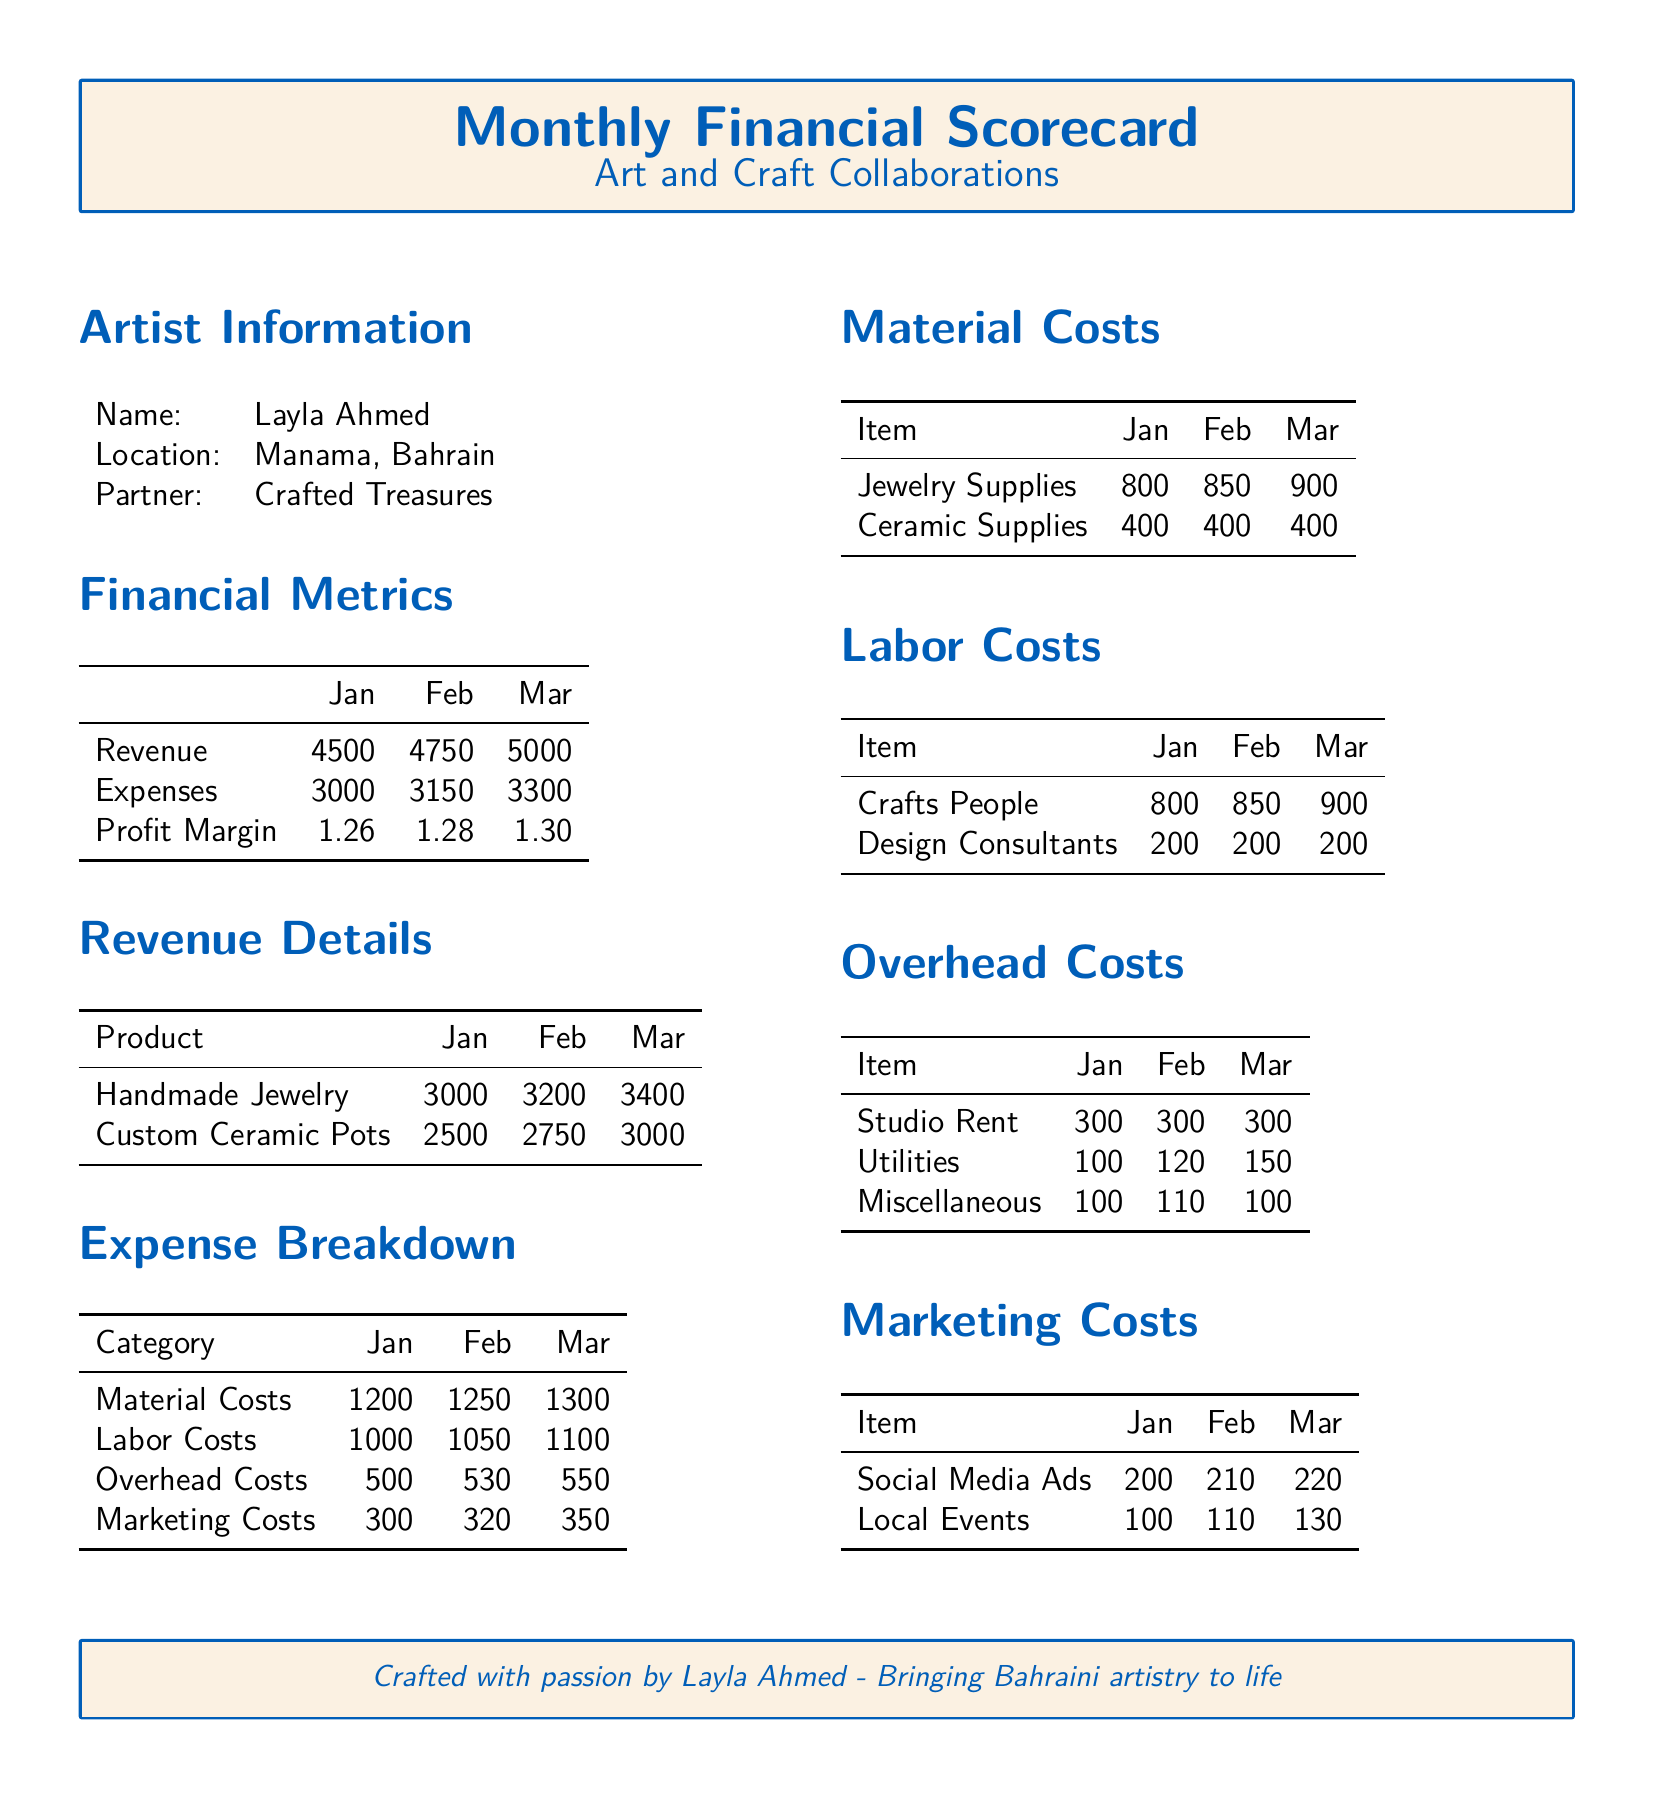What is the total revenue for March? The total revenue for March can be found in the financial metrics section of the document.
Answer: 5000 What are the total expenses for February? The total expenses for February are listed in the financial metrics section of the document.
Answer: 3150 What is the profit margin for January? The profit margin for January is found in the financial metrics section, where it is stated explicitly.
Answer: 1.26 How much did the handmade jewelry revenue increase from January to March? The increase in revenue for handmade jewelry can be calculated by comparing the values from January and March.
Answer: 400 What category had the highest expense in March? The expense category with the highest value can be determined by looking at the expense breakdown for March.
Answer: Labor Costs What were the marketing costs in January? The marketing costs for January are specifically detailed in the expense breakdown section.
Answer: 300 How many items are listed under Material Costs? The document lists the items under Material Costs, and we can count them for the answer.
Answer: 2 Who is the partner in the collaboration? The partner is named in the artist information section of the document.
Answer: Crafted Treasures What was the increase in utility costs from February to March? The increase in utility costs can be derived from the numbers given for those months in the overhead costs section.
Answer: 30 